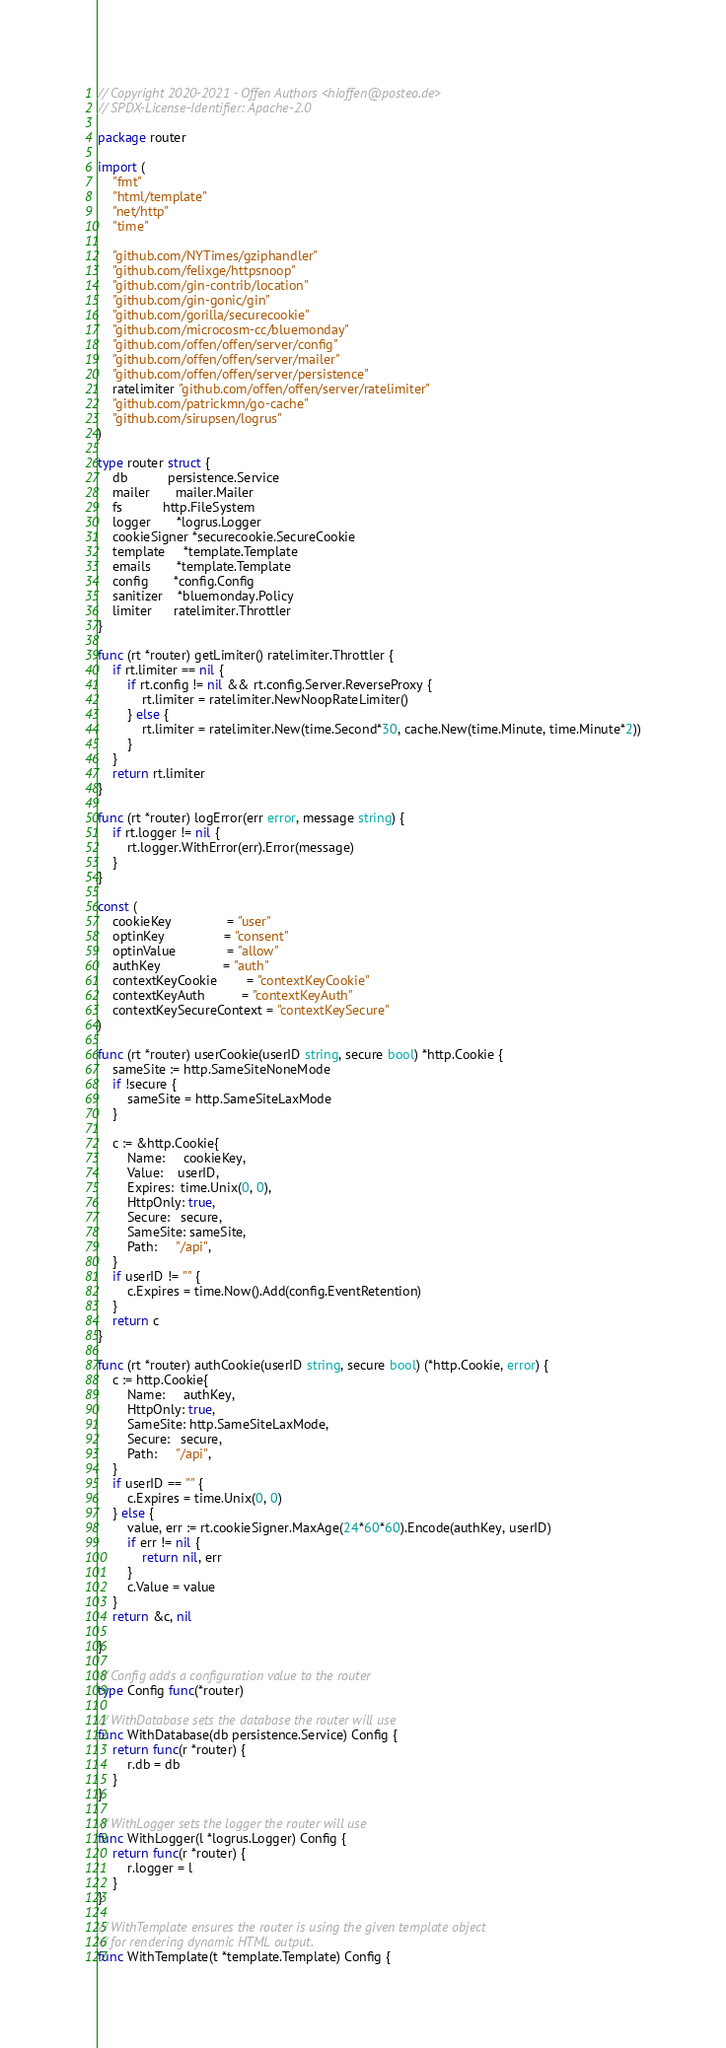<code> <loc_0><loc_0><loc_500><loc_500><_Go_>// Copyright 2020-2021 - Offen Authors <hioffen@posteo.de>
// SPDX-License-Identifier: Apache-2.0

package router

import (
	"fmt"
	"html/template"
	"net/http"
	"time"

	"github.com/NYTimes/gziphandler"
	"github.com/felixge/httpsnoop"
	"github.com/gin-contrib/location"
	"github.com/gin-gonic/gin"
	"github.com/gorilla/securecookie"
	"github.com/microcosm-cc/bluemonday"
	"github.com/offen/offen/server/config"
	"github.com/offen/offen/server/mailer"
	"github.com/offen/offen/server/persistence"
	ratelimiter "github.com/offen/offen/server/ratelimiter"
	"github.com/patrickmn/go-cache"
	"github.com/sirupsen/logrus"
)

type router struct {
	db           persistence.Service
	mailer       mailer.Mailer
	fs           http.FileSystem
	logger       *logrus.Logger
	cookieSigner *securecookie.SecureCookie
	template     *template.Template
	emails       *template.Template
	config       *config.Config
	sanitizer    *bluemonday.Policy
	limiter      ratelimiter.Throttler
}

func (rt *router) getLimiter() ratelimiter.Throttler {
	if rt.limiter == nil {
		if rt.config != nil && rt.config.Server.ReverseProxy {
			rt.limiter = ratelimiter.NewNoopRateLimiter()
		} else {
			rt.limiter = ratelimiter.New(time.Second*30, cache.New(time.Minute, time.Minute*2))
		}
	}
	return rt.limiter
}

func (rt *router) logError(err error, message string) {
	if rt.logger != nil {
		rt.logger.WithError(err).Error(message)
	}
}

const (
	cookieKey               = "user"
	optinKey                = "consent"
	optinValue              = "allow"
	authKey                 = "auth"
	contextKeyCookie        = "contextKeyCookie"
	contextKeyAuth          = "contextKeyAuth"
	contextKeySecureContext = "contextKeySecure"
)

func (rt *router) userCookie(userID string, secure bool) *http.Cookie {
	sameSite := http.SameSiteNoneMode
	if !secure {
		sameSite = http.SameSiteLaxMode
	}

	c := &http.Cookie{
		Name:     cookieKey,
		Value:    userID,
		Expires:  time.Unix(0, 0),
		HttpOnly: true,
		Secure:   secure,
		SameSite: sameSite,
		Path:     "/api",
	}
	if userID != "" {
		c.Expires = time.Now().Add(config.EventRetention)
	}
	return c
}

func (rt *router) authCookie(userID string, secure bool) (*http.Cookie, error) {
	c := http.Cookie{
		Name:     authKey,
		HttpOnly: true,
		SameSite: http.SameSiteLaxMode,
		Secure:   secure,
		Path:     "/api",
	}
	if userID == "" {
		c.Expires = time.Unix(0, 0)
	} else {
		value, err := rt.cookieSigner.MaxAge(24*60*60).Encode(authKey, userID)
		if err != nil {
			return nil, err
		}
		c.Value = value
	}
	return &c, nil

}

// Config adds a configuration value to the router
type Config func(*router)

// WithDatabase sets the database the router will use
func WithDatabase(db persistence.Service) Config {
	return func(r *router) {
		r.db = db
	}
}

// WithLogger sets the logger the router will use
func WithLogger(l *logrus.Logger) Config {
	return func(r *router) {
		r.logger = l
	}
}

// WithTemplate ensures the router is using the given template object
// for rendering dynamic HTML output.
func WithTemplate(t *template.Template) Config {</code> 